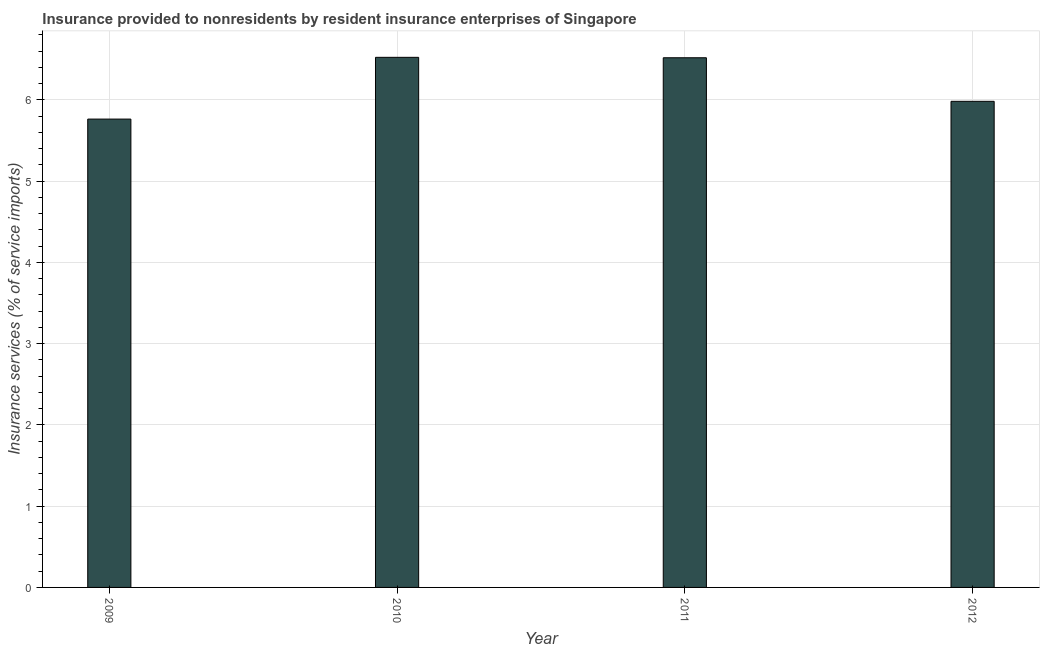Does the graph contain grids?
Ensure brevity in your answer.  Yes. What is the title of the graph?
Ensure brevity in your answer.  Insurance provided to nonresidents by resident insurance enterprises of Singapore. What is the label or title of the X-axis?
Keep it short and to the point. Year. What is the label or title of the Y-axis?
Ensure brevity in your answer.  Insurance services (% of service imports). What is the insurance and financial services in 2011?
Your response must be concise. 6.52. Across all years, what is the maximum insurance and financial services?
Offer a terse response. 6.52. Across all years, what is the minimum insurance and financial services?
Offer a terse response. 5.76. What is the sum of the insurance and financial services?
Offer a terse response. 24.79. What is the difference between the insurance and financial services in 2011 and 2012?
Your answer should be compact. 0.54. What is the average insurance and financial services per year?
Your response must be concise. 6.2. What is the median insurance and financial services?
Provide a succinct answer. 6.25. In how many years, is the insurance and financial services greater than 0.4 %?
Keep it short and to the point. 4. What is the ratio of the insurance and financial services in 2009 to that in 2010?
Ensure brevity in your answer.  0.88. Is the insurance and financial services in 2010 less than that in 2012?
Ensure brevity in your answer.  No. What is the difference between the highest and the second highest insurance and financial services?
Provide a succinct answer. 0.01. Is the sum of the insurance and financial services in 2010 and 2012 greater than the maximum insurance and financial services across all years?
Give a very brief answer. Yes. What is the difference between the highest and the lowest insurance and financial services?
Ensure brevity in your answer.  0.76. Are all the bars in the graph horizontal?
Keep it short and to the point. No. How many years are there in the graph?
Give a very brief answer. 4. What is the difference between two consecutive major ticks on the Y-axis?
Offer a very short reply. 1. Are the values on the major ticks of Y-axis written in scientific E-notation?
Your response must be concise. No. What is the Insurance services (% of service imports) in 2009?
Keep it short and to the point. 5.76. What is the Insurance services (% of service imports) of 2010?
Keep it short and to the point. 6.52. What is the Insurance services (% of service imports) in 2011?
Your response must be concise. 6.52. What is the Insurance services (% of service imports) of 2012?
Give a very brief answer. 5.98. What is the difference between the Insurance services (% of service imports) in 2009 and 2010?
Provide a short and direct response. -0.76. What is the difference between the Insurance services (% of service imports) in 2009 and 2011?
Provide a short and direct response. -0.75. What is the difference between the Insurance services (% of service imports) in 2009 and 2012?
Keep it short and to the point. -0.22. What is the difference between the Insurance services (% of service imports) in 2010 and 2011?
Make the answer very short. 0.01. What is the difference between the Insurance services (% of service imports) in 2010 and 2012?
Provide a succinct answer. 0.54. What is the difference between the Insurance services (% of service imports) in 2011 and 2012?
Offer a terse response. 0.54. What is the ratio of the Insurance services (% of service imports) in 2009 to that in 2010?
Offer a very short reply. 0.88. What is the ratio of the Insurance services (% of service imports) in 2009 to that in 2011?
Ensure brevity in your answer.  0.88. What is the ratio of the Insurance services (% of service imports) in 2010 to that in 2011?
Your response must be concise. 1. What is the ratio of the Insurance services (% of service imports) in 2010 to that in 2012?
Offer a terse response. 1.09. What is the ratio of the Insurance services (% of service imports) in 2011 to that in 2012?
Provide a succinct answer. 1.09. 